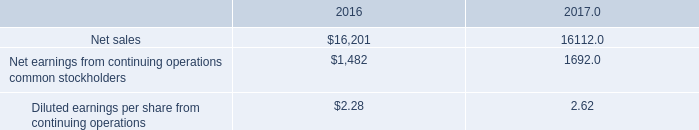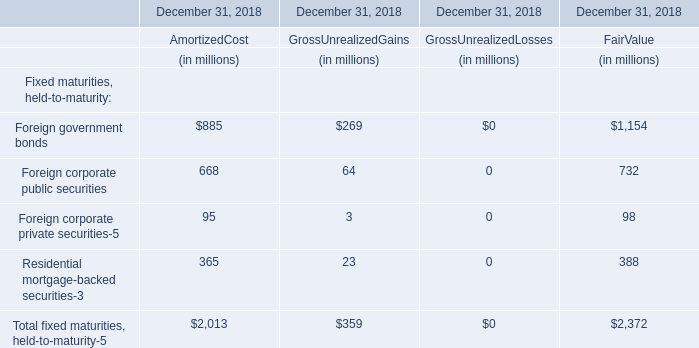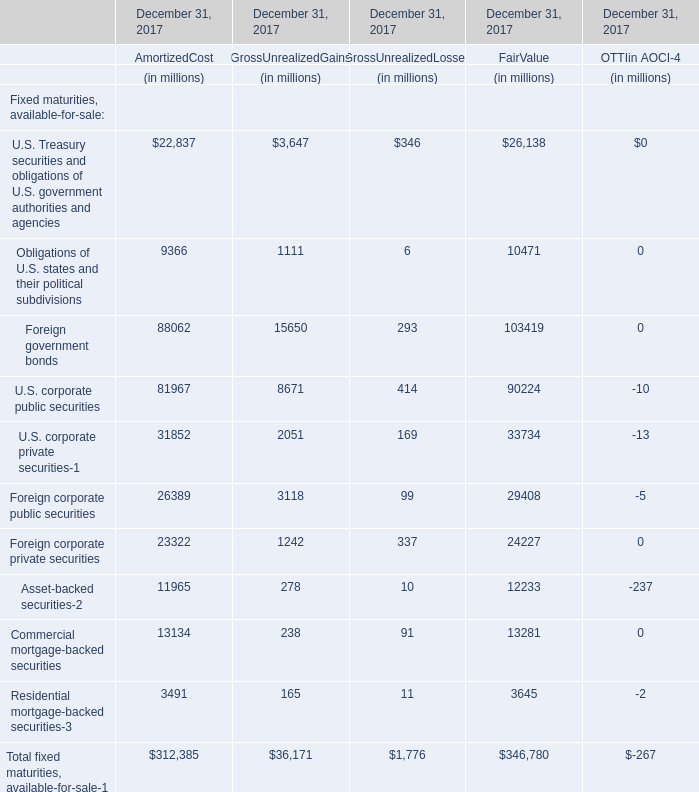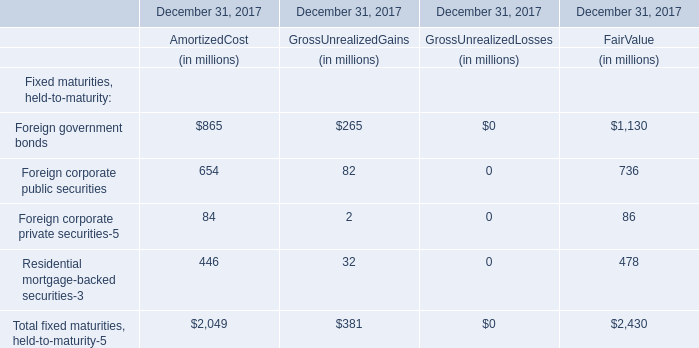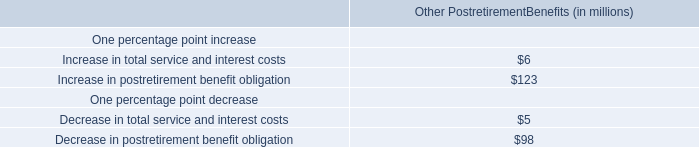Which fixed maturities, held-to-maturity-5 exceeds 40 % of total in 2018? 
Computations: (2372 * 0.4)
Answer: 948.8. 